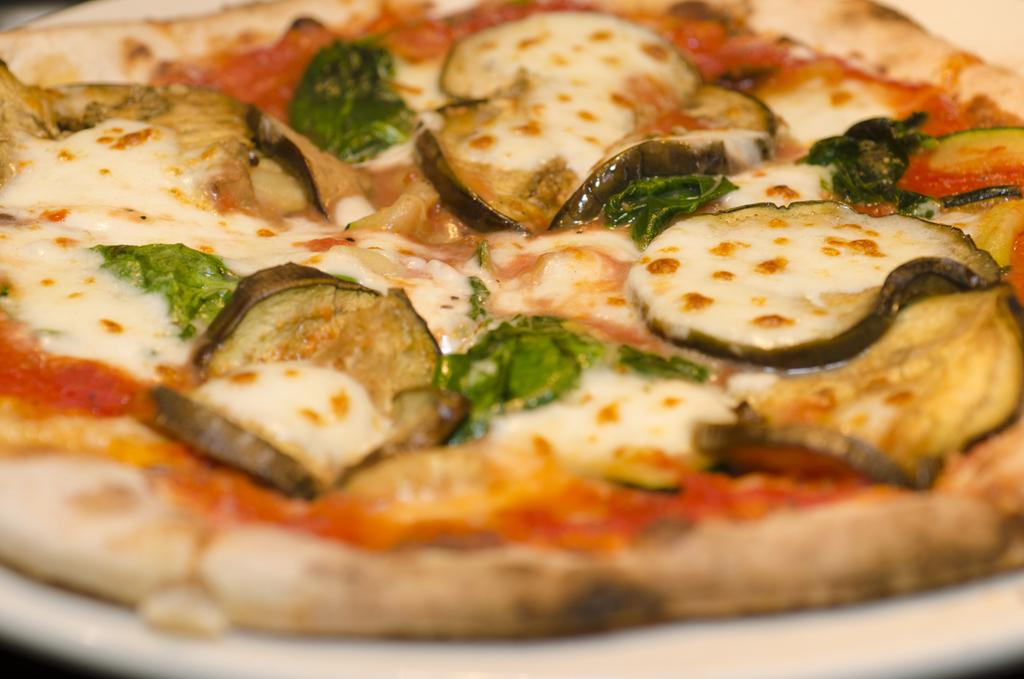What is the main subject of the image? There is a food item on a plate in the image. What type of rake is being used to prepare the food in the image? There is no rake present in the image; it only features a food item on a plate. On what type of table is the food item placed in the image? The fact provided does not mention a table, so we cannot determine if there is one in the image or its type. 